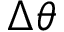Convert formula to latex. <formula><loc_0><loc_0><loc_500><loc_500>\Delta \theta</formula> 